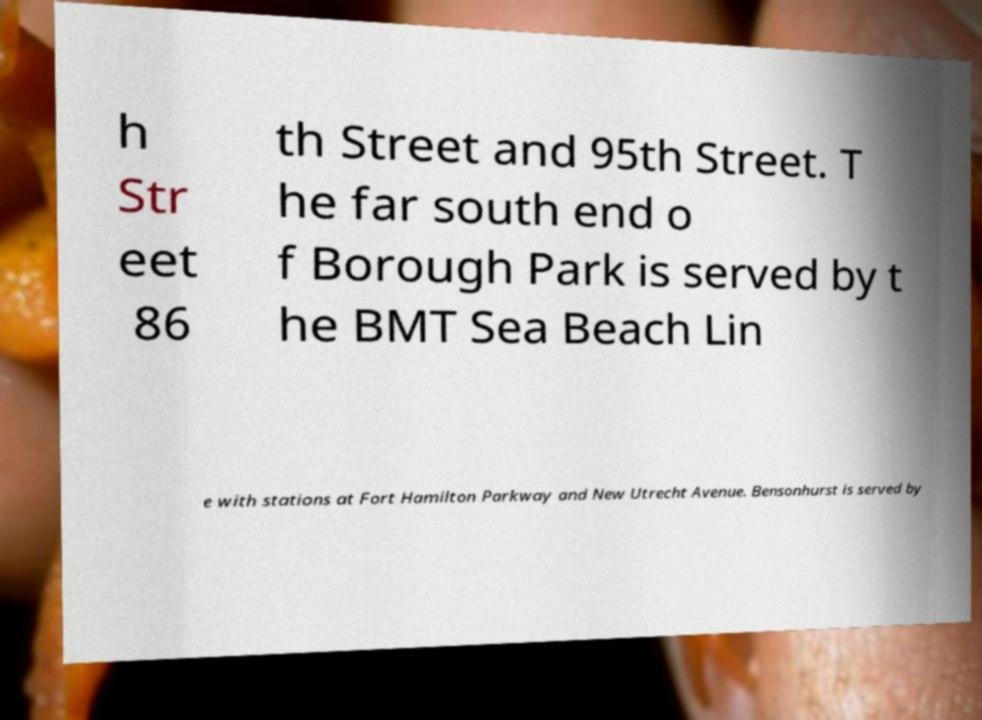Please read and relay the text visible in this image. What does it say? h Str eet 86 th Street and 95th Street. T he far south end o f Borough Park is served by t he BMT Sea Beach Lin e with stations at Fort Hamilton Parkway and New Utrecht Avenue. Bensonhurst is served by 